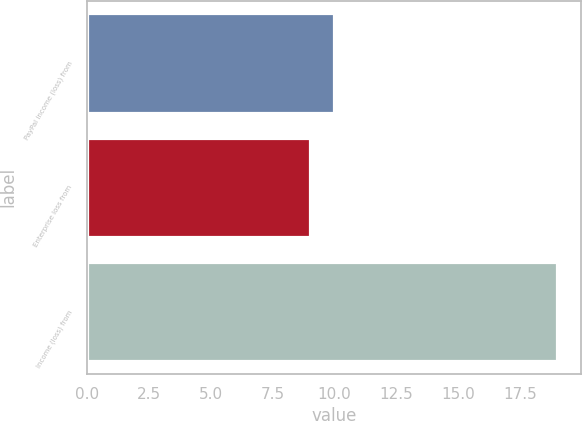Convert chart. <chart><loc_0><loc_0><loc_500><loc_500><bar_chart><fcel>PayPal income (loss) from<fcel>Enterprise loss from<fcel>Income (loss) from<nl><fcel>10<fcel>9<fcel>19<nl></chart> 